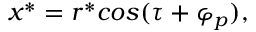<formula> <loc_0><loc_0><loc_500><loc_500>x ^ { * } = r ^ { * } \cos ( \tau + \varphi _ { p } ) ,</formula> 